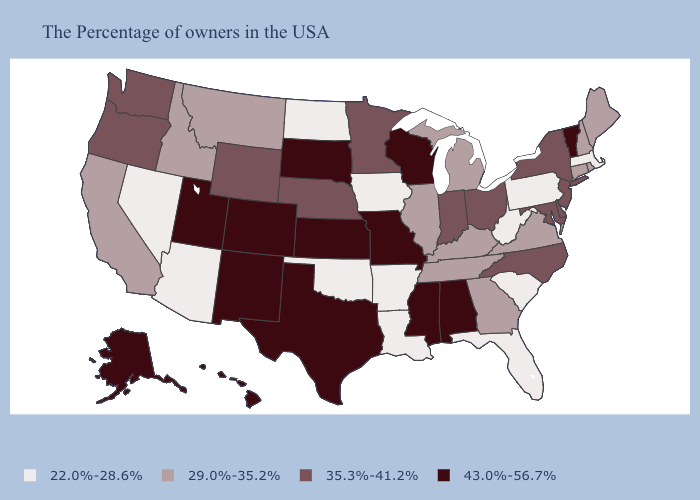What is the value of New York?
Quick response, please. 35.3%-41.2%. Among the states that border Iowa , does Minnesota have the lowest value?
Keep it brief. No. What is the value of Virginia?
Concise answer only. 29.0%-35.2%. What is the value of New Mexico?
Short answer required. 43.0%-56.7%. How many symbols are there in the legend?
Write a very short answer. 4. What is the value of New Jersey?
Write a very short answer. 35.3%-41.2%. Does Nevada have the highest value in the West?
Short answer required. No. What is the value of Missouri?
Be succinct. 43.0%-56.7%. Name the states that have a value in the range 22.0%-28.6%?
Concise answer only. Massachusetts, Pennsylvania, South Carolina, West Virginia, Florida, Louisiana, Arkansas, Iowa, Oklahoma, North Dakota, Arizona, Nevada. Does Nevada have the same value as Idaho?
Give a very brief answer. No. Name the states that have a value in the range 35.3%-41.2%?
Quick response, please. New York, New Jersey, Delaware, Maryland, North Carolina, Ohio, Indiana, Minnesota, Nebraska, Wyoming, Washington, Oregon. What is the value of Hawaii?
Short answer required. 43.0%-56.7%. Name the states that have a value in the range 29.0%-35.2%?
Write a very short answer. Maine, Rhode Island, New Hampshire, Connecticut, Virginia, Georgia, Michigan, Kentucky, Tennessee, Illinois, Montana, Idaho, California. Name the states that have a value in the range 22.0%-28.6%?
Answer briefly. Massachusetts, Pennsylvania, South Carolina, West Virginia, Florida, Louisiana, Arkansas, Iowa, Oklahoma, North Dakota, Arizona, Nevada. Name the states that have a value in the range 43.0%-56.7%?
Give a very brief answer. Vermont, Alabama, Wisconsin, Mississippi, Missouri, Kansas, Texas, South Dakota, Colorado, New Mexico, Utah, Alaska, Hawaii. 